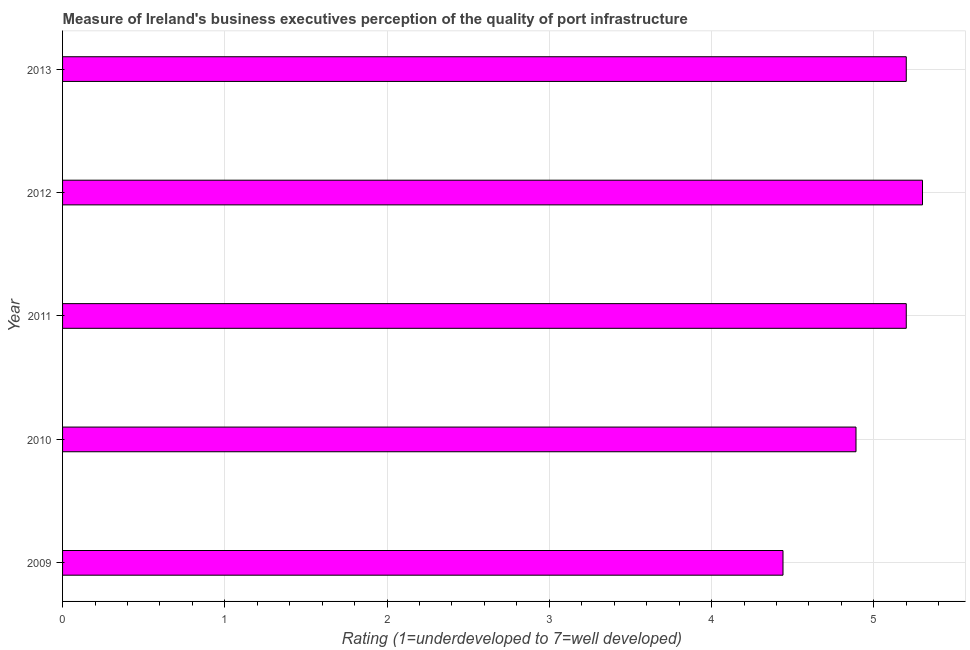Does the graph contain any zero values?
Make the answer very short. No. Does the graph contain grids?
Offer a very short reply. Yes. What is the title of the graph?
Ensure brevity in your answer.  Measure of Ireland's business executives perception of the quality of port infrastructure. What is the label or title of the X-axis?
Your answer should be compact. Rating (1=underdeveloped to 7=well developed) . What is the rating measuring quality of port infrastructure in 2012?
Your answer should be compact. 5.3. Across all years, what is the minimum rating measuring quality of port infrastructure?
Offer a very short reply. 4.44. What is the sum of the rating measuring quality of port infrastructure?
Your response must be concise. 25.03. What is the difference between the rating measuring quality of port infrastructure in 2010 and 2013?
Keep it short and to the point. -0.31. What is the average rating measuring quality of port infrastructure per year?
Offer a very short reply. 5.01. What is the median rating measuring quality of port infrastructure?
Keep it short and to the point. 5.2. Is the rating measuring quality of port infrastructure in 2009 less than that in 2011?
Offer a terse response. Yes. Is the difference between the rating measuring quality of port infrastructure in 2010 and 2013 greater than the difference between any two years?
Ensure brevity in your answer.  No. What is the difference between the highest and the second highest rating measuring quality of port infrastructure?
Offer a very short reply. 0.1. What is the difference between the highest and the lowest rating measuring quality of port infrastructure?
Your response must be concise. 0.86. How many bars are there?
Your answer should be very brief. 5. How many years are there in the graph?
Provide a short and direct response. 5. What is the difference between two consecutive major ticks on the X-axis?
Offer a terse response. 1. Are the values on the major ticks of X-axis written in scientific E-notation?
Your answer should be very brief. No. What is the Rating (1=underdeveloped to 7=well developed)  of 2009?
Keep it short and to the point. 4.44. What is the Rating (1=underdeveloped to 7=well developed)  of 2010?
Your response must be concise. 4.89. What is the Rating (1=underdeveloped to 7=well developed)  in 2012?
Provide a succinct answer. 5.3. What is the difference between the Rating (1=underdeveloped to 7=well developed)  in 2009 and 2010?
Provide a succinct answer. -0.45. What is the difference between the Rating (1=underdeveloped to 7=well developed)  in 2009 and 2011?
Ensure brevity in your answer.  -0.76. What is the difference between the Rating (1=underdeveloped to 7=well developed)  in 2009 and 2012?
Your answer should be very brief. -0.86. What is the difference between the Rating (1=underdeveloped to 7=well developed)  in 2009 and 2013?
Give a very brief answer. -0.76. What is the difference between the Rating (1=underdeveloped to 7=well developed)  in 2010 and 2011?
Your response must be concise. -0.31. What is the difference between the Rating (1=underdeveloped to 7=well developed)  in 2010 and 2012?
Provide a short and direct response. -0.41. What is the difference between the Rating (1=underdeveloped to 7=well developed)  in 2010 and 2013?
Give a very brief answer. -0.31. What is the difference between the Rating (1=underdeveloped to 7=well developed)  in 2011 and 2013?
Give a very brief answer. 0. What is the ratio of the Rating (1=underdeveloped to 7=well developed)  in 2009 to that in 2010?
Make the answer very short. 0.91. What is the ratio of the Rating (1=underdeveloped to 7=well developed)  in 2009 to that in 2011?
Your response must be concise. 0.85. What is the ratio of the Rating (1=underdeveloped to 7=well developed)  in 2009 to that in 2012?
Ensure brevity in your answer.  0.84. What is the ratio of the Rating (1=underdeveloped to 7=well developed)  in 2009 to that in 2013?
Provide a succinct answer. 0.85. What is the ratio of the Rating (1=underdeveloped to 7=well developed)  in 2010 to that in 2012?
Offer a very short reply. 0.92. What is the ratio of the Rating (1=underdeveloped to 7=well developed)  in 2010 to that in 2013?
Keep it short and to the point. 0.94. What is the ratio of the Rating (1=underdeveloped to 7=well developed)  in 2011 to that in 2012?
Give a very brief answer. 0.98. What is the ratio of the Rating (1=underdeveloped to 7=well developed)  in 2011 to that in 2013?
Provide a short and direct response. 1. 